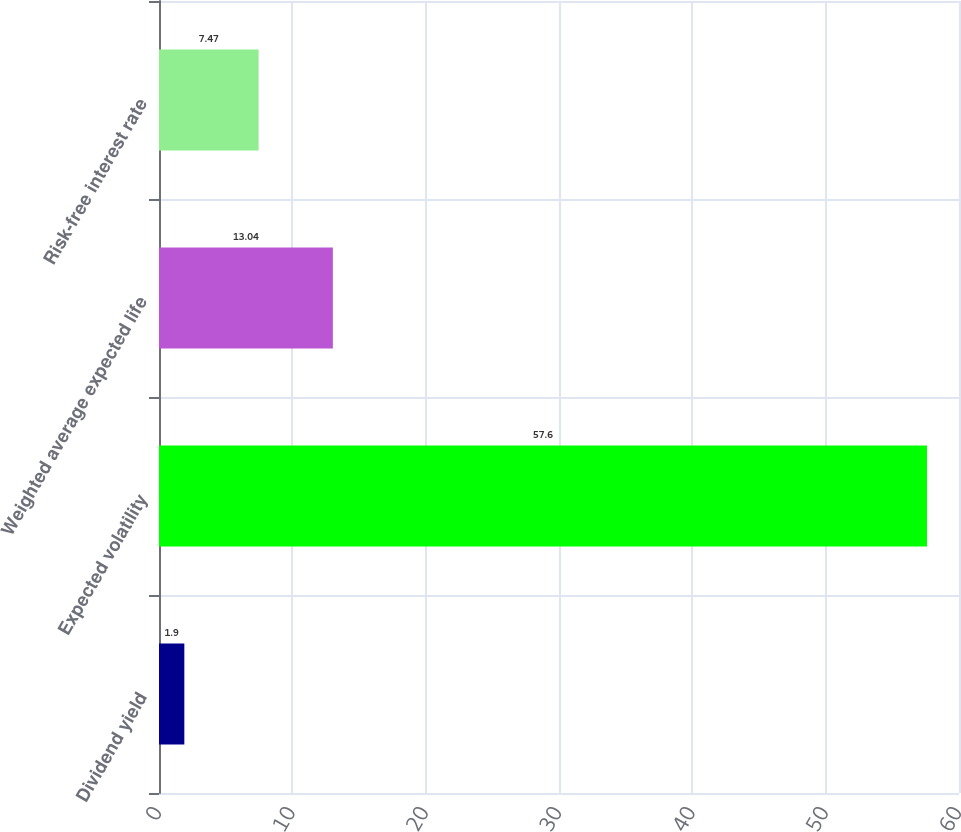<chart> <loc_0><loc_0><loc_500><loc_500><bar_chart><fcel>Dividend yield<fcel>Expected volatility<fcel>Weighted average expected life<fcel>Risk-free interest rate<nl><fcel>1.9<fcel>57.6<fcel>13.04<fcel>7.47<nl></chart> 